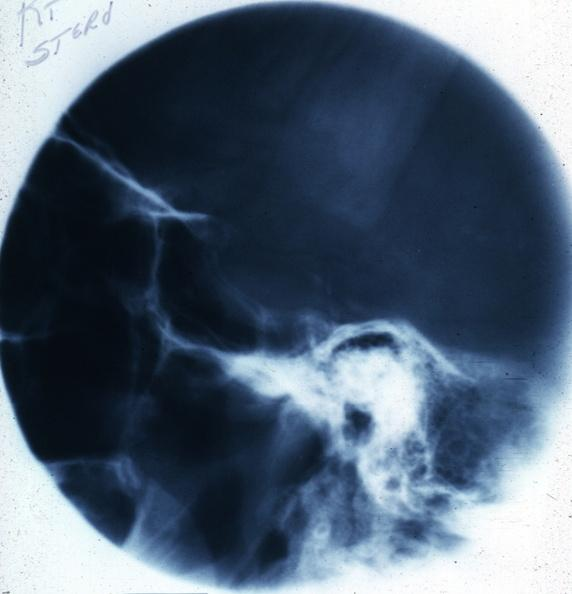s siamese twins present?
Answer the question using a single word or phrase. No 